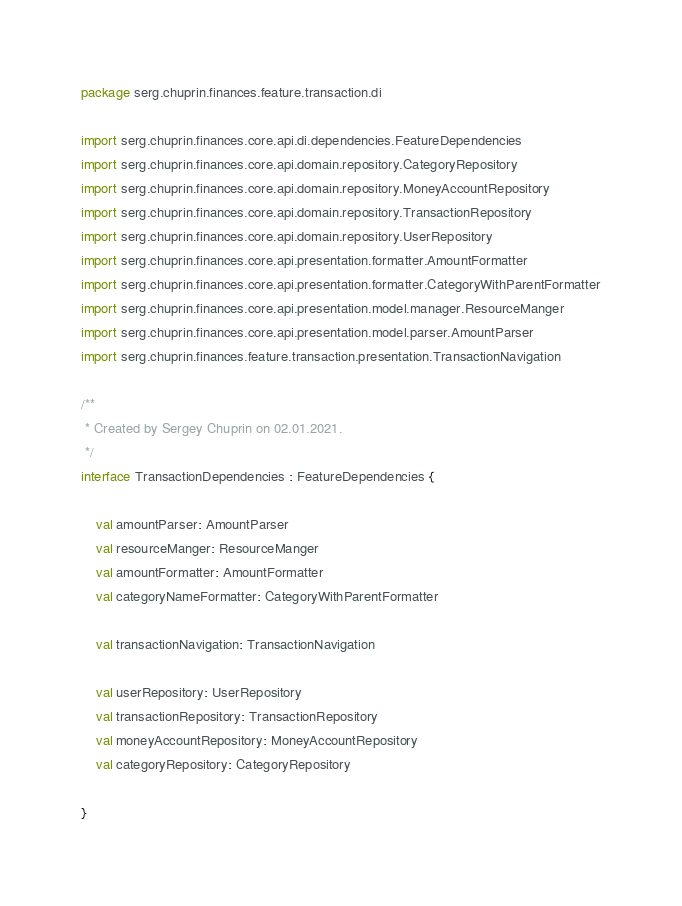<code> <loc_0><loc_0><loc_500><loc_500><_Kotlin_>package serg.chuprin.finances.feature.transaction.di

import serg.chuprin.finances.core.api.di.dependencies.FeatureDependencies
import serg.chuprin.finances.core.api.domain.repository.CategoryRepository
import serg.chuprin.finances.core.api.domain.repository.MoneyAccountRepository
import serg.chuprin.finances.core.api.domain.repository.TransactionRepository
import serg.chuprin.finances.core.api.domain.repository.UserRepository
import serg.chuprin.finances.core.api.presentation.formatter.AmountFormatter
import serg.chuprin.finances.core.api.presentation.formatter.CategoryWithParentFormatter
import serg.chuprin.finances.core.api.presentation.model.manager.ResourceManger
import serg.chuprin.finances.core.api.presentation.model.parser.AmountParser
import serg.chuprin.finances.feature.transaction.presentation.TransactionNavigation

/**
 * Created by Sergey Chuprin on 02.01.2021.
 */
interface TransactionDependencies : FeatureDependencies {

    val amountParser: AmountParser
    val resourceManger: ResourceManger
    val amountFormatter: AmountFormatter
    val categoryNameFormatter: CategoryWithParentFormatter

    val transactionNavigation: TransactionNavigation

    val userRepository: UserRepository
    val transactionRepository: TransactionRepository
    val moneyAccountRepository: MoneyAccountRepository
    val categoryRepository: CategoryRepository

}</code> 